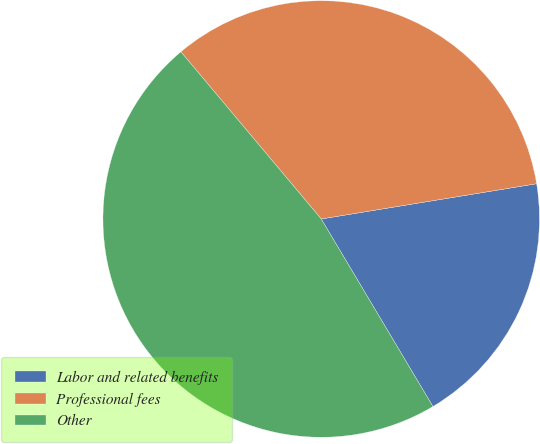Convert chart. <chart><loc_0><loc_0><loc_500><loc_500><pie_chart><fcel>Labor and related benefits<fcel>Professional fees<fcel>Other<nl><fcel>19.03%<fcel>33.53%<fcel>47.43%<nl></chart> 